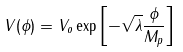Convert formula to latex. <formula><loc_0><loc_0><loc_500><loc_500>V ( \phi ) = V _ { o } \exp \left [ - \sqrt { \lambda } \frac { \phi } { M _ { p } } \right ]</formula> 